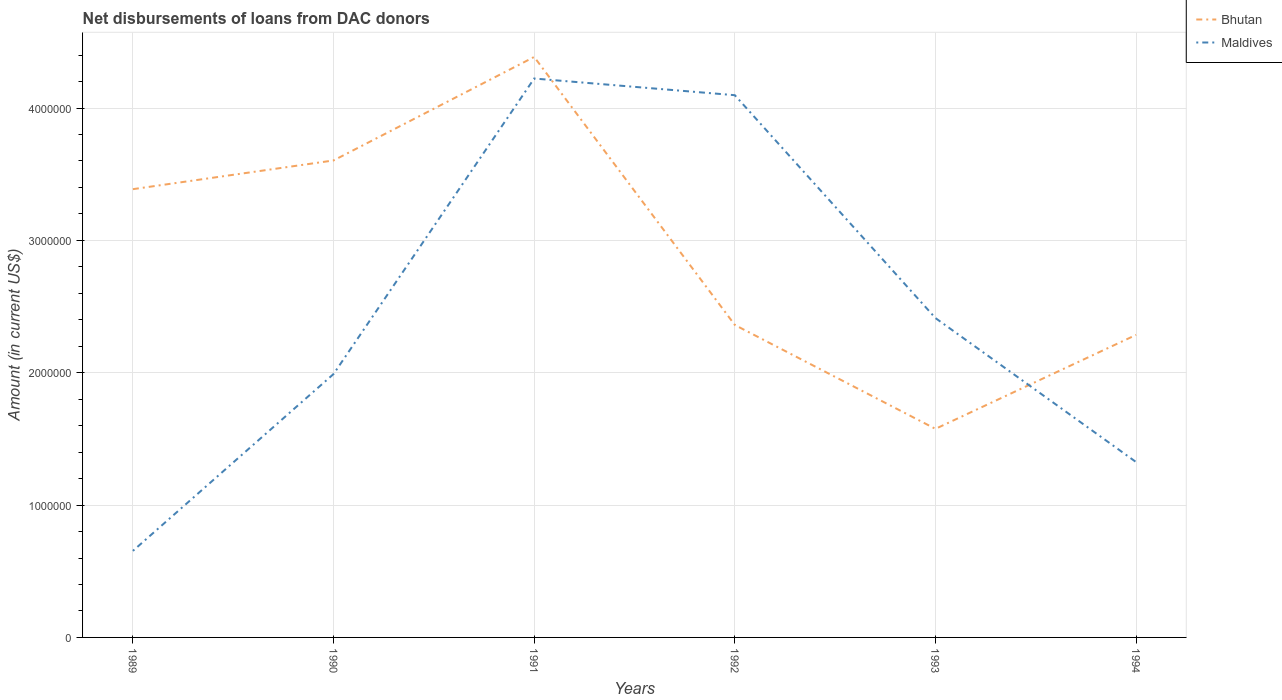Does the line corresponding to Maldives intersect with the line corresponding to Bhutan?
Your answer should be very brief. Yes. Is the number of lines equal to the number of legend labels?
Your response must be concise. Yes. Across all years, what is the maximum amount of loans disbursed in Maldives?
Your response must be concise. 6.54e+05. What is the total amount of loans disbursed in Maldives in the graph?
Your answer should be very brief. 1.26e+05. What is the difference between the highest and the second highest amount of loans disbursed in Bhutan?
Make the answer very short. 2.81e+06. What is the difference between the highest and the lowest amount of loans disbursed in Bhutan?
Give a very brief answer. 3. Is the amount of loans disbursed in Bhutan strictly greater than the amount of loans disbursed in Maldives over the years?
Keep it short and to the point. No. How many lines are there?
Ensure brevity in your answer.  2. What is the difference between two consecutive major ticks on the Y-axis?
Provide a succinct answer. 1.00e+06. Does the graph contain grids?
Provide a short and direct response. Yes. Where does the legend appear in the graph?
Ensure brevity in your answer.  Top right. How are the legend labels stacked?
Your answer should be compact. Vertical. What is the title of the graph?
Provide a short and direct response. Net disbursements of loans from DAC donors. Does "Canada" appear as one of the legend labels in the graph?
Provide a short and direct response. No. What is the label or title of the X-axis?
Your answer should be compact. Years. What is the Amount (in current US$) in Bhutan in 1989?
Give a very brief answer. 3.39e+06. What is the Amount (in current US$) in Maldives in 1989?
Make the answer very short. 6.54e+05. What is the Amount (in current US$) of Bhutan in 1990?
Your answer should be very brief. 3.60e+06. What is the Amount (in current US$) of Maldives in 1990?
Your response must be concise. 1.99e+06. What is the Amount (in current US$) in Bhutan in 1991?
Make the answer very short. 4.39e+06. What is the Amount (in current US$) in Maldives in 1991?
Your answer should be very brief. 4.22e+06. What is the Amount (in current US$) in Bhutan in 1992?
Ensure brevity in your answer.  2.36e+06. What is the Amount (in current US$) in Maldives in 1992?
Keep it short and to the point. 4.10e+06. What is the Amount (in current US$) of Bhutan in 1993?
Offer a terse response. 1.58e+06. What is the Amount (in current US$) of Maldives in 1993?
Keep it short and to the point. 2.41e+06. What is the Amount (in current US$) in Bhutan in 1994?
Your response must be concise. 2.29e+06. What is the Amount (in current US$) in Maldives in 1994?
Ensure brevity in your answer.  1.32e+06. Across all years, what is the maximum Amount (in current US$) in Bhutan?
Provide a succinct answer. 4.39e+06. Across all years, what is the maximum Amount (in current US$) of Maldives?
Make the answer very short. 4.22e+06. Across all years, what is the minimum Amount (in current US$) in Bhutan?
Offer a terse response. 1.58e+06. Across all years, what is the minimum Amount (in current US$) in Maldives?
Make the answer very short. 6.54e+05. What is the total Amount (in current US$) of Bhutan in the graph?
Provide a short and direct response. 1.76e+07. What is the total Amount (in current US$) of Maldives in the graph?
Offer a terse response. 1.47e+07. What is the difference between the Amount (in current US$) in Bhutan in 1989 and that in 1990?
Keep it short and to the point. -2.17e+05. What is the difference between the Amount (in current US$) in Maldives in 1989 and that in 1990?
Give a very brief answer. -1.34e+06. What is the difference between the Amount (in current US$) of Bhutan in 1989 and that in 1991?
Offer a terse response. -9.99e+05. What is the difference between the Amount (in current US$) in Maldives in 1989 and that in 1991?
Provide a short and direct response. -3.57e+06. What is the difference between the Amount (in current US$) of Bhutan in 1989 and that in 1992?
Give a very brief answer. 1.03e+06. What is the difference between the Amount (in current US$) in Maldives in 1989 and that in 1992?
Offer a terse response. -3.44e+06. What is the difference between the Amount (in current US$) of Bhutan in 1989 and that in 1993?
Offer a very short reply. 1.81e+06. What is the difference between the Amount (in current US$) in Maldives in 1989 and that in 1993?
Give a very brief answer. -1.76e+06. What is the difference between the Amount (in current US$) of Bhutan in 1989 and that in 1994?
Provide a short and direct response. 1.10e+06. What is the difference between the Amount (in current US$) of Maldives in 1989 and that in 1994?
Keep it short and to the point. -6.71e+05. What is the difference between the Amount (in current US$) in Bhutan in 1990 and that in 1991?
Give a very brief answer. -7.82e+05. What is the difference between the Amount (in current US$) of Maldives in 1990 and that in 1991?
Ensure brevity in your answer.  -2.23e+06. What is the difference between the Amount (in current US$) in Bhutan in 1990 and that in 1992?
Offer a terse response. 1.24e+06. What is the difference between the Amount (in current US$) of Maldives in 1990 and that in 1992?
Provide a short and direct response. -2.11e+06. What is the difference between the Amount (in current US$) of Bhutan in 1990 and that in 1993?
Make the answer very short. 2.03e+06. What is the difference between the Amount (in current US$) in Maldives in 1990 and that in 1993?
Your answer should be compact. -4.23e+05. What is the difference between the Amount (in current US$) in Bhutan in 1990 and that in 1994?
Your answer should be compact. 1.32e+06. What is the difference between the Amount (in current US$) in Maldives in 1990 and that in 1994?
Offer a terse response. 6.65e+05. What is the difference between the Amount (in current US$) of Bhutan in 1991 and that in 1992?
Provide a succinct answer. 2.02e+06. What is the difference between the Amount (in current US$) in Maldives in 1991 and that in 1992?
Ensure brevity in your answer.  1.26e+05. What is the difference between the Amount (in current US$) in Bhutan in 1991 and that in 1993?
Make the answer very short. 2.81e+06. What is the difference between the Amount (in current US$) in Maldives in 1991 and that in 1993?
Give a very brief answer. 1.81e+06. What is the difference between the Amount (in current US$) in Bhutan in 1991 and that in 1994?
Your answer should be compact. 2.10e+06. What is the difference between the Amount (in current US$) of Maldives in 1991 and that in 1994?
Make the answer very short. 2.90e+06. What is the difference between the Amount (in current US$) in Bhutan in 1992 and that in 1993?
Offer a very short reply. 7.85e+05. What is the difference between the Amount (in current US$) in Maldives in 1992 and that in 1993?
Ensure brevity in your answer.  1.68e+06. What is the difference between the Amount (in current US$) of Bhutan in 1992 and that in 1994?
Provide a succinct answer. 7.50e+04. What is the difference between the Amount (in current US$) of Maldives in 1992 and that in 1994?
Your answer should be compact. 2.77e+06. What is the difference between the Amount (in current US$) in Bhutan in 1993 and that in 1994?
Your response must be concise. -7.10e+05. What is the difference between the Amount (in current US$) of Maldives in 1993 and that in 1994?
Ensure brevity in your answer.  1.09e+06. What is the difference between the Amount (in current US$) of Bhutan in 1989 and the Amount (in current US$) of Maldives in 1990?
Ensure brevity in your answer.  1.40e+06. What is the difference between the Amount (in current US$) in Bhutan in 1989 and the Amount (in current US$) in Maldives in 1991?
Offer a very short reply. -8.36e+05. What is the difference between the Amount (in current US$) of Bhutan in 1989 and the Amount (in current US$) of Maldives in 1992?
Offer a very short reply. -7.10e+05. What is the difference between the Amount (in current US$) of Bhutan in 1989 and the Amount (in current US$) of Maldives in 1993?
Give a very brief answer. 9.74e+05. What is the difference between the Amount (in current US$) in Bhutan in 1989 and the Amount (in current US$) in Maldives in 1994?
Make the answer very short. 2.06e+06. What is the difference between the Amount (in current US$) in Bhutan in 1990 and the Amount (in current US$) in Maldives in 1991?
Provide a succinct answer. -6.19e+05. What is the difference between the Amount (in current US$) of Bhutan in 1990 and the Amount (in current US$) of Maldives in 1992?
Provide a succinct answer. -4.93e+05. What is the difference between the Amount (in current US$) of Bhutan in 1990 and the Amount (in current US$) of Maldives in 1993?
Keep it short and to the point. 1.19e+06. What is the difference between the Amount (in current US$) in Bhutan in 1990 and the Amount (in current US$) in Maldives in 1994?
Offer a terse response. 2.28e+06. What is the difference between the Amount (in current US$) of Bhutan in 1991 and the Amount (in current US$) of Maldives in 1992?
Ensure brevity in your answer.  2.89e+05. What is the difference between the Amount (in current US$) of Bhutan in 1991 and the Amount (in current US$) of Maldives in 1993?
Provide a short and direct response. 1.97e+06. What is the difference between the Amount (in current US$) in Bhutan in 1991 and the Amount (in current US$) in Maldives in 1994?
Your response must be concise. 3.06e+06. What is the difference between the Amount (in current US$) in Bhutan in 1992 and the Amount (in current US$) in Maldives in 1993?
Keep it short and to the point. -5.20e+04. What is the difference between the Amount (in current US$) of Bhutan in 1992 and the Amount (in current US$) of Maldives in 1994?
Your response must be concise. 1.04e+06. What is the difference between the Amount (in current US$) of Bhutan in 1993 and the Amount (in current US$) of Maldives in 1994?
Provide a succinct answer. 2.51e+05. What is the average Amount (in current US$) in Bhutan per year?
Make the answer very short. 2.93e+06. What is the average Amount (in current US$) in Maldives per year?
Give a very brief answer. 2.45e+06. In the year 1989, what is the difference between the Amount (in current US$) of Bhutan and Amount (in current US$) of Maldives?
Provide a succinct answer. 2.73e+06. In the year 1990, what is the difference between the Amount (in current US$) in Bhutan and Amount (in current US$) in Maldives?
Your answer should be very brief. 1.61e+06. In the year 1991, what is the difference between the Amount (in current US$) in Bhutan and Amount (in current US$) in Maldives?
Your response must be concise. 1.63e+05. In the year 1992, what is the difference between the Amount (in current US$) in Bhutan and Amount (in current US$) in Maldives?
Provide a short and direct response. -1.74e+06. In the year 1993, what is the difference between the Amount (in current US$) of Bhutan and Amount (in current US$) of Maldives?
Provide a succinct answer. -8.37e+05. In the year 1994, what is the difference between the Amount (in current US$) of Bhutan and Amount (in current US$) of Maldives?
Your answer should be very brief. 9.61e+05. What is the ratio of the Amount (in current US$) in Bhutan in 1989 to that in 1990?
Your answer should be very brief. 0.94. What is the ratio of the Amount (in current US$) of Maldives in 1989 to that in 1990?
Your response must be concise. 0.33. What is the ratio of the Amount (in current US$) in Bhutan in 1989 to that in 1991?
Your answer should be compact. 0.77. What is the ratio of the Amount (in current US$) of Maldives in 1989 to that in 1991?
Ensure brevity in your answer.  0.15. What is the ratio of the Amount (in current US$) in Bhutan in 1989 to that in 1992?
Offer a terse response. 1.43. What is the ratio of the Amount (in current US$) in Maldives in 1989 to that in 1992?
Ensure brevity in your answer.  0.16. What is the ratio of the Amount (in current US$) of Bhutan in 1989 to that in 1993?
Your answer should be very brief. 2.15. What is the ratio of the Amount (in current US$) in Maldives in 1989 to that in 1993?
Give a very brief answer. 0.27. What is the ratio of the Amount (in current US$) of Bhutan in 1989 to that in 1994?
Your answer should be compact. 1.48. What is the ratio of the Amount (in current US$) in Maldives in 1989 to that in 1994?
Give a very brief answer. 0.49. What is the ratio of the Amount (in current US$) of Bhutan in 1990 to that in 1991?
Offer a terse response. 0.82. What is the ratio of the Amount (in current US$) in Maldives in 1990 to that in 1991?
Ensure brevity in your answer.  0.47. What is the ratio of the Amount (in current US$) in Bhutan in 1990 to that in 1992?
Provide a short and direct response. 1.53. What is the ratio of the Amount (in current US$) of Maldives in 1990 to that in 1992?
Ensure brevity in your answer.  0.49. What is the ratio of the Amount (in current US$) in Bhutan in 1990 to that in 1993?
Your answer should be compact. 2.29. What is the ratio of the Amount (in current US$) in Maldives in 1990 to that in 1993?
Your answer should be very brief. 0.82. What is the ratio of the Amount (in current US$) of Bhutan in 1990 to that in 1994?
Your response must be concise. 1.58. What is the ratio of the Amount (in current US$) of Maldives in 1990 to that in 1994?
Offer a terse response. 1.5. What is the ratio of the Amount (in current US$) in Bhutan in 1991 to that in 1992?
Make the answer very short. 1.86. What is the ratio of the Amount (in current US$) in Maldives in 1991 to that in 1992?
Your response must be concise. 1.03. What is the ratio of the Amount (in current US$) in Bhutan in 1991 to that in 1993?
Your response must be concise. 2.78. What is the ratio of the Amount (in current US$) of Maldives in 1991 to that in 1993?
Provide a succinct answer. 1.75. What is the ratio of the Amount (in current US$) in Bhutan in 1991 to that in 1994?
Make the answer very short. 1.92. What is the ratio of the Amount (in current US$) in Maldives in 1991 to that in 1994?
Ensure brevity in your answer.  3.19. What is the ratio of the Amount (in current US$) in Bhutan in 1992 to that in 1993?
Make the answer very short. 1.5. What is the ratio of the Amount (in current US$) in Maldives in 1992 to that in 1993?
Keep it short and to the point. 1.7. What is the ratio of the Amount (in current US$) in Bhutan in 1992 to that in 1994?
Provide a succinct answer. 1.03. What is the ratio of the Amount (in current US$) in Maldives in 1992 to that in 1994?
Your answer should be compact. 3.09. What is the ratio of the Amount (in current US$) in Bhutan in 1993 to that in 1994?
Give a very brief answer. 0.69. What is the ratio of the Amount (in current US$) in Maldives in 1993 to that in 1994?
Ensure brevity in your answer.  1.82. What is the difference between the highest and the second highest Amount (in current US$) in Bhutan?
Keep it short and to the point. 7.82e+05. What is the difference between the highest and the second highest Amount (in current US$) in Maldives?
Give a very brief answer. 1.26e+05. What is the difference between the highest and the lowest Amount (in current US$) of Bhutan?
Your answer should be very brief. 2.81e+06. What is the difference between the highest and the lowest Amount (in current US$) in Maldives?
Ensure brevity in your answer.  3.57e+06. 